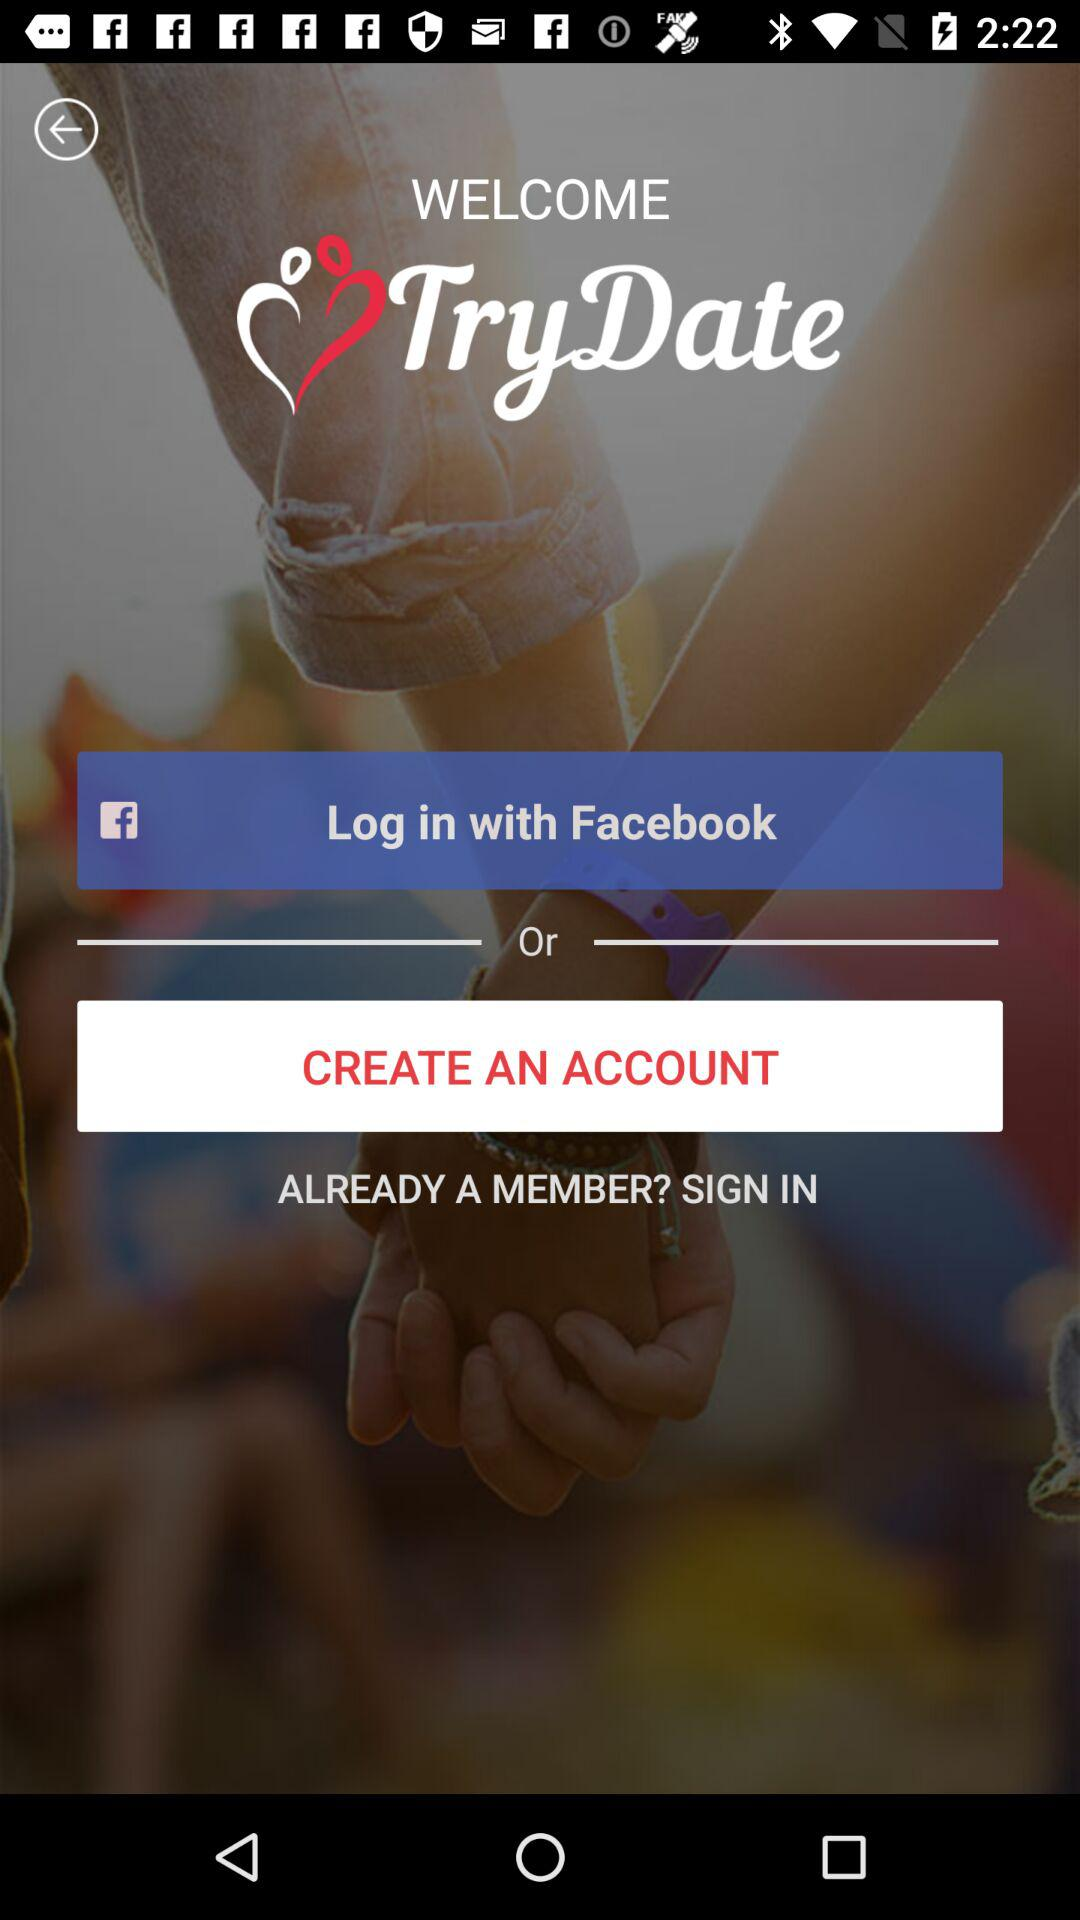What is the application name? The application name is "TryDate". 